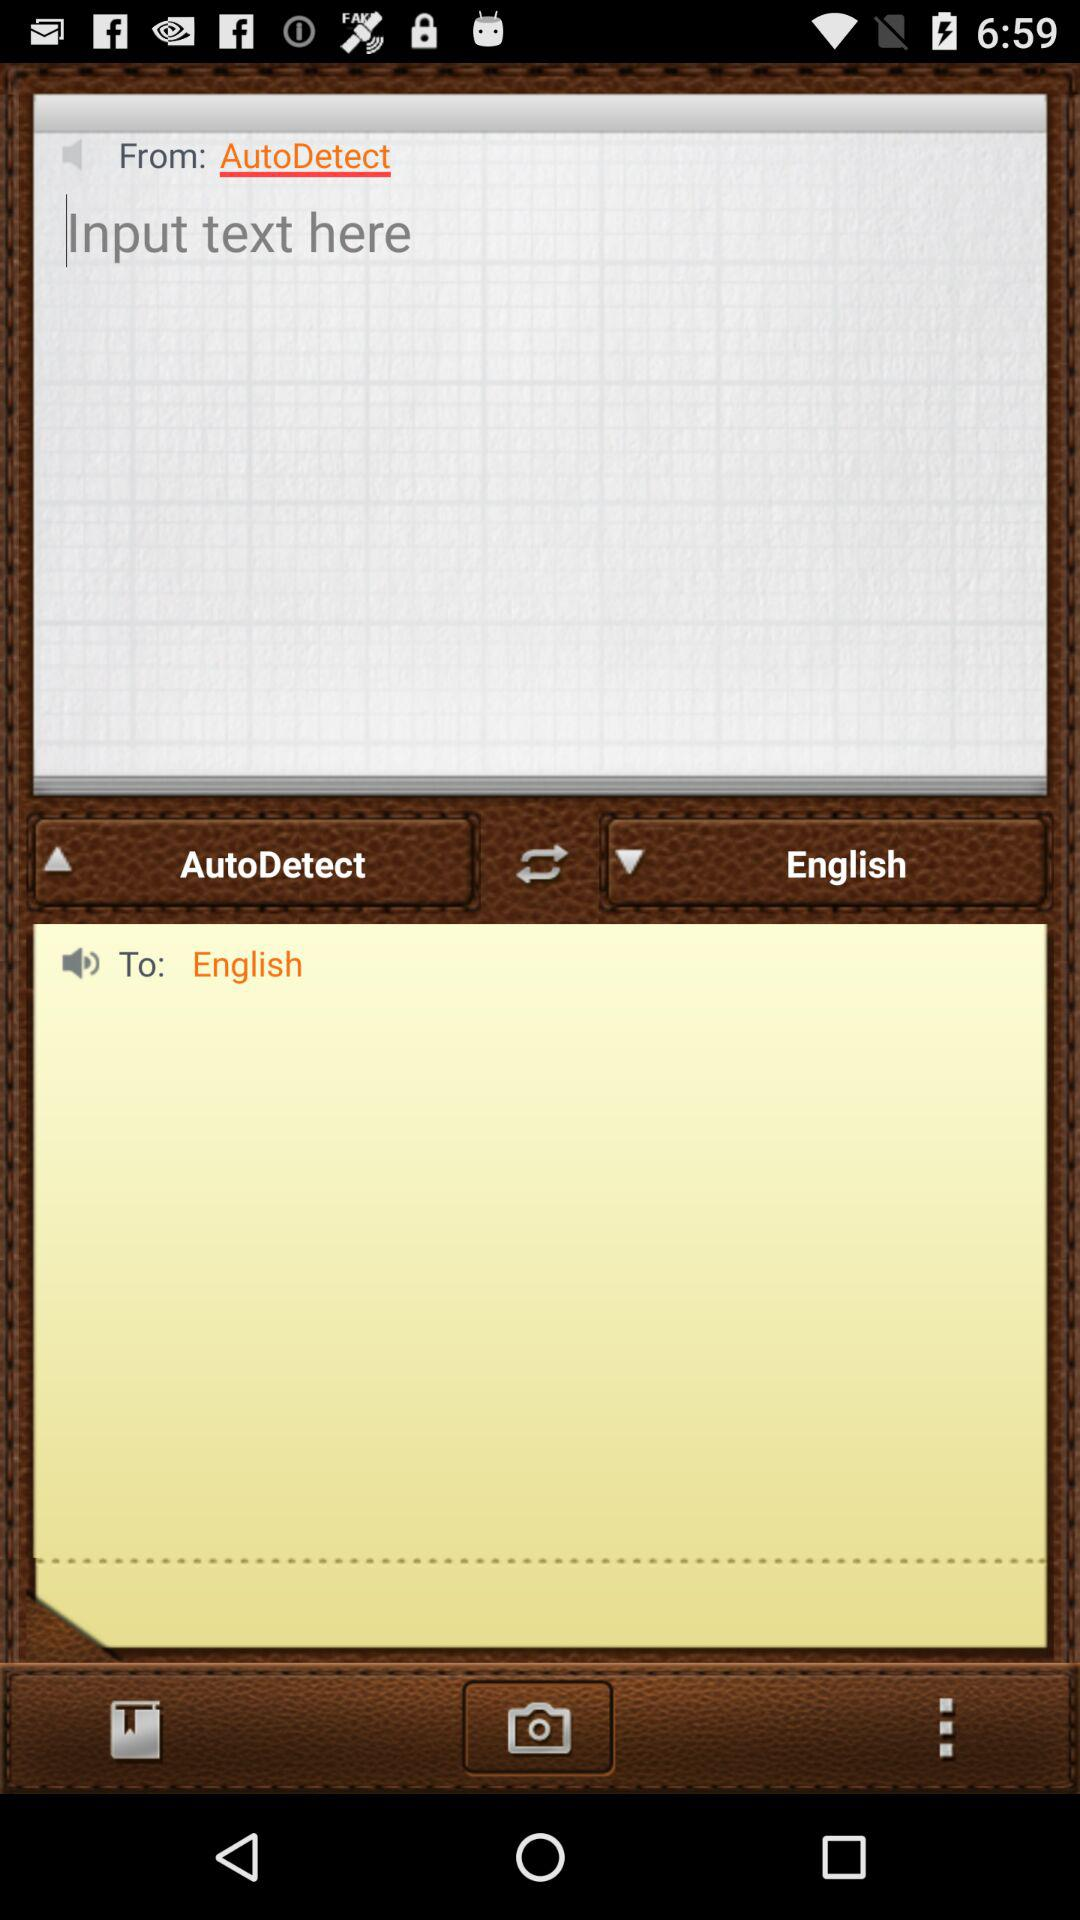To what language can the translation be done? The language is English. 